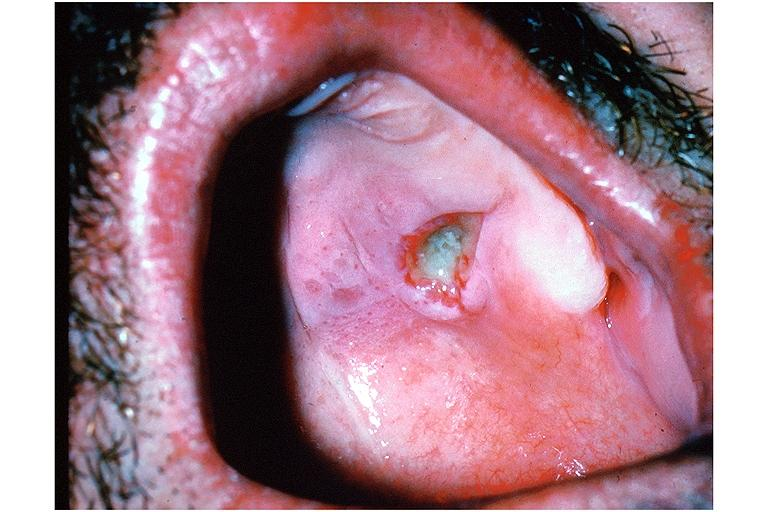s gross present?
Answer the question using a single word or phrase. No 